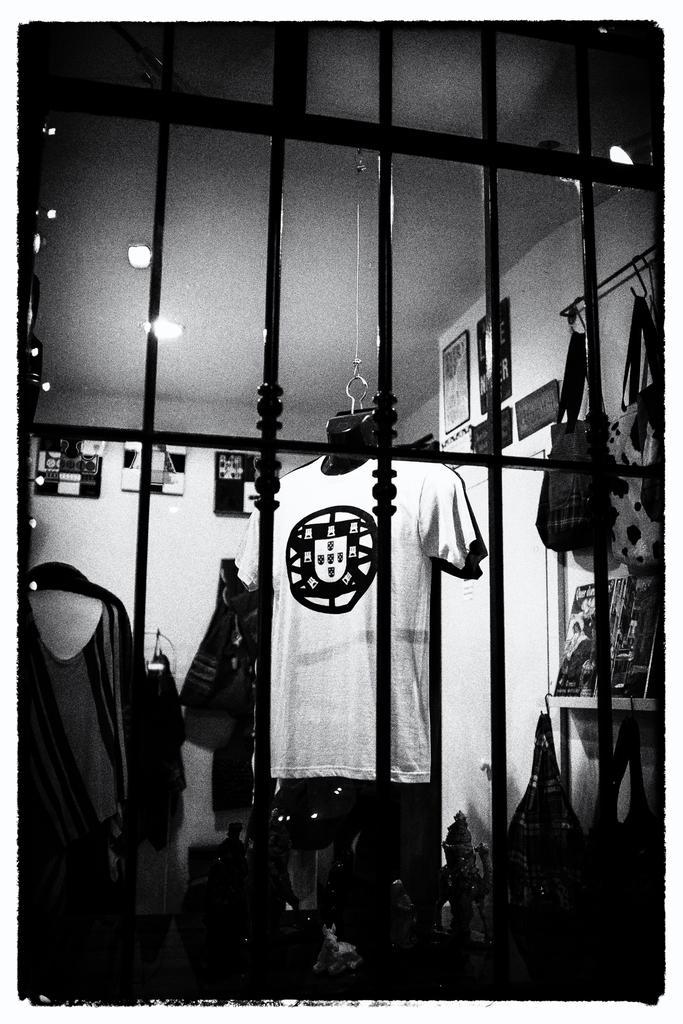Please provide a concise description of this image. In this image in the foreground there is a fence, and in the background there are some clothes and some bags are hanging and on the wall there are some photo frames. At the bottom there are some bags and boxes and on the top there is ceiling and some lights. 